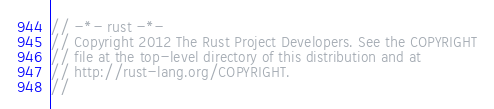<code> <loc_0><loc_0><loc_500><loc_500><_Rust_>// -*- rust -*-
// Copyright 2012 The Rust Project Developers. See the COPYRIGHT
// file at the top-level directory of this distribution and at
// http://rust-lang.org/COPYRIGHT.
//</code> 